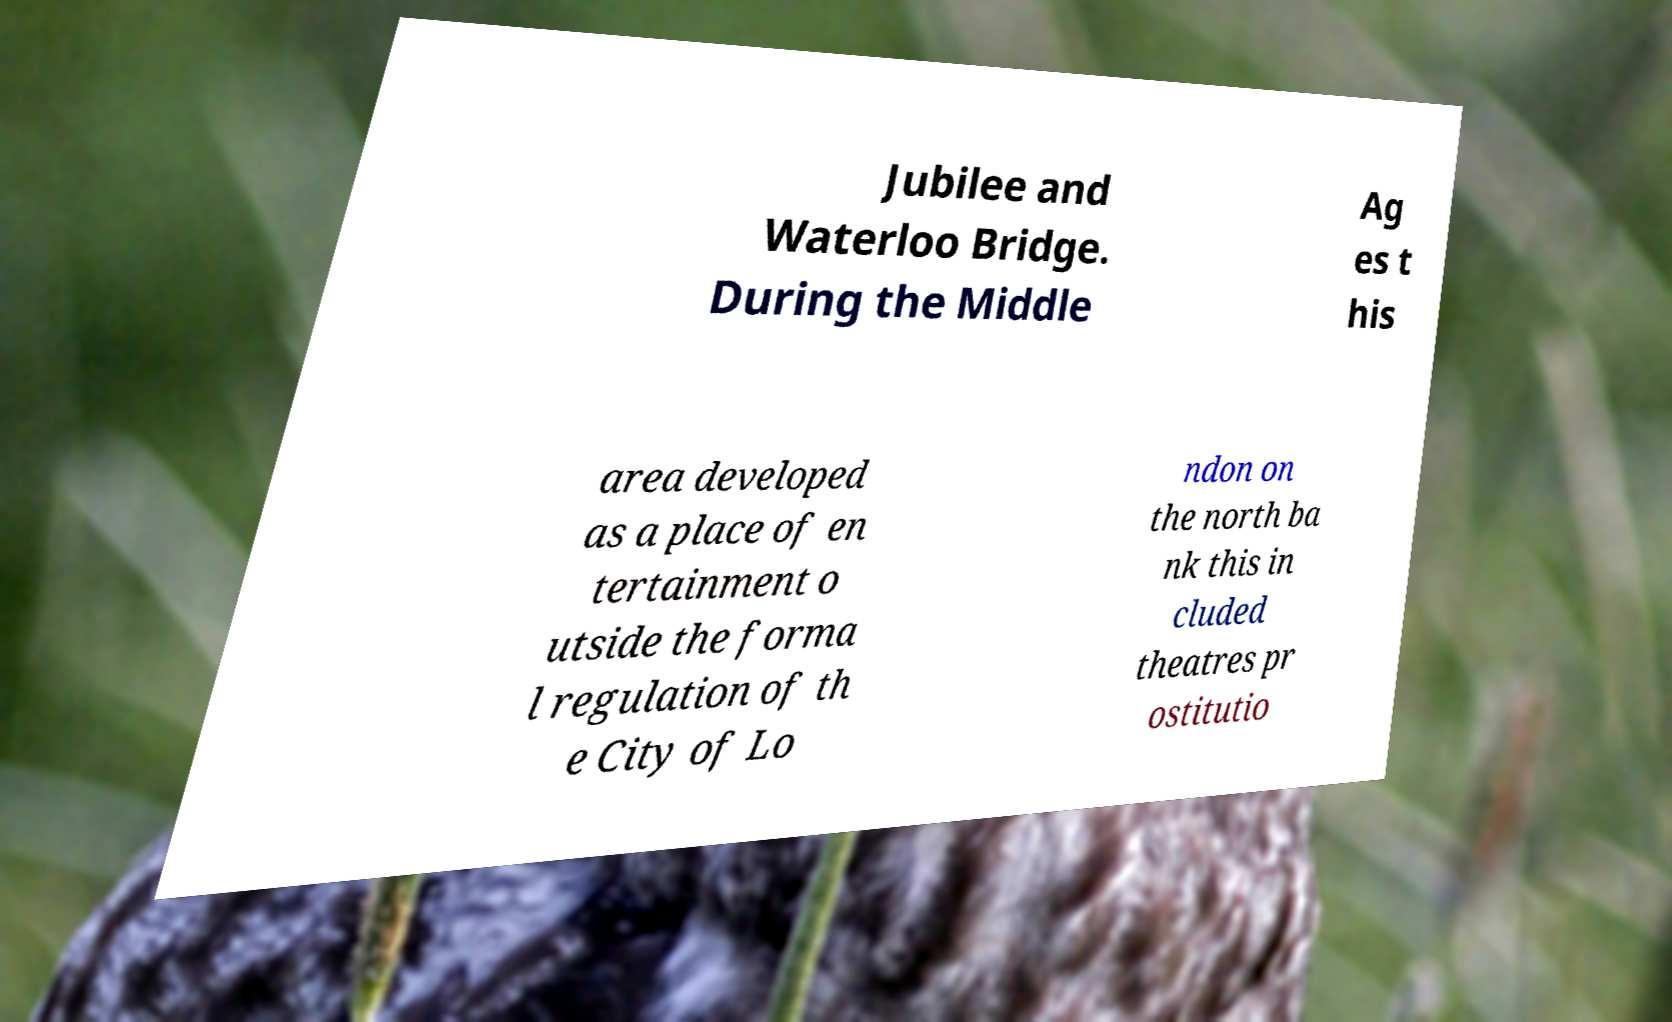There's text embedded in this image that I need extracted. Can you transcribe it verbatim? Jubilee and Waterloo Bridge. During the Middle Ag es t his area developed as a place of en tertainment o utside the forma l regulation of th e City of Lo ndon on the north ba nk this in cluded theatres pr ostitutio 